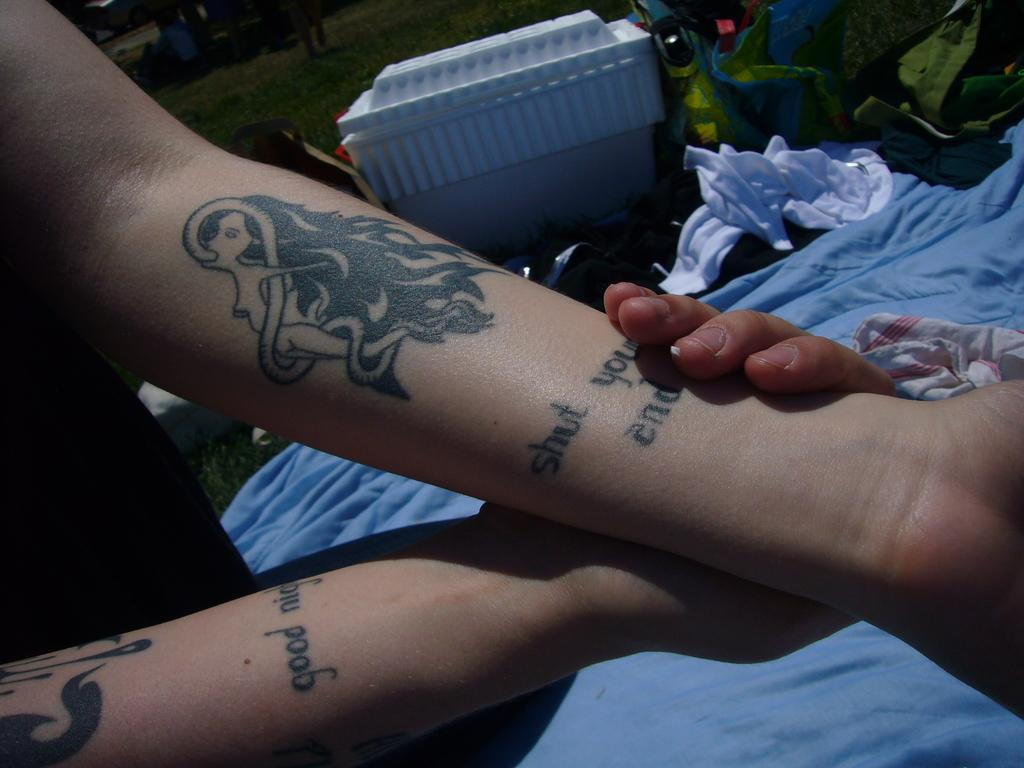What is visible on the hand in the image? There are tattoos on a hand in the image. What can be seen behind the hand? There is cloth visible behind the hand. What type of objects are present in the image? There are bags in the image. What type of cord is being used to say good-bye in the image? There is no cord or good-bye gesture present in the image. 